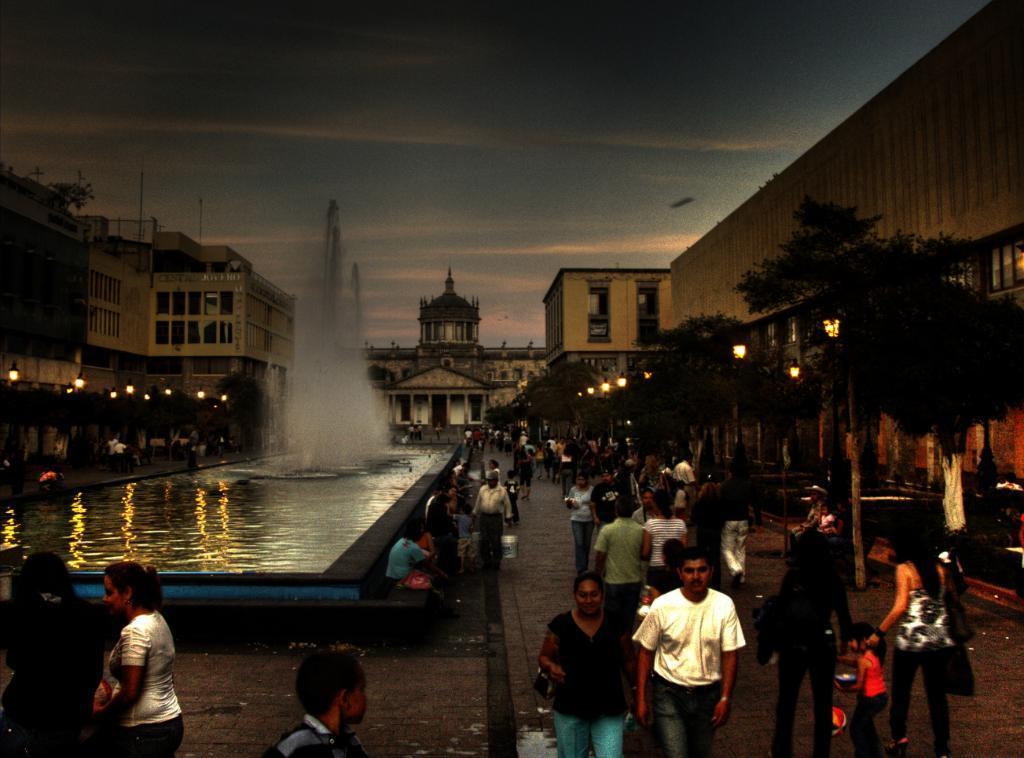Describe this image in one or two sentences. People are present. There are trees, fountain, lights and buildings. 